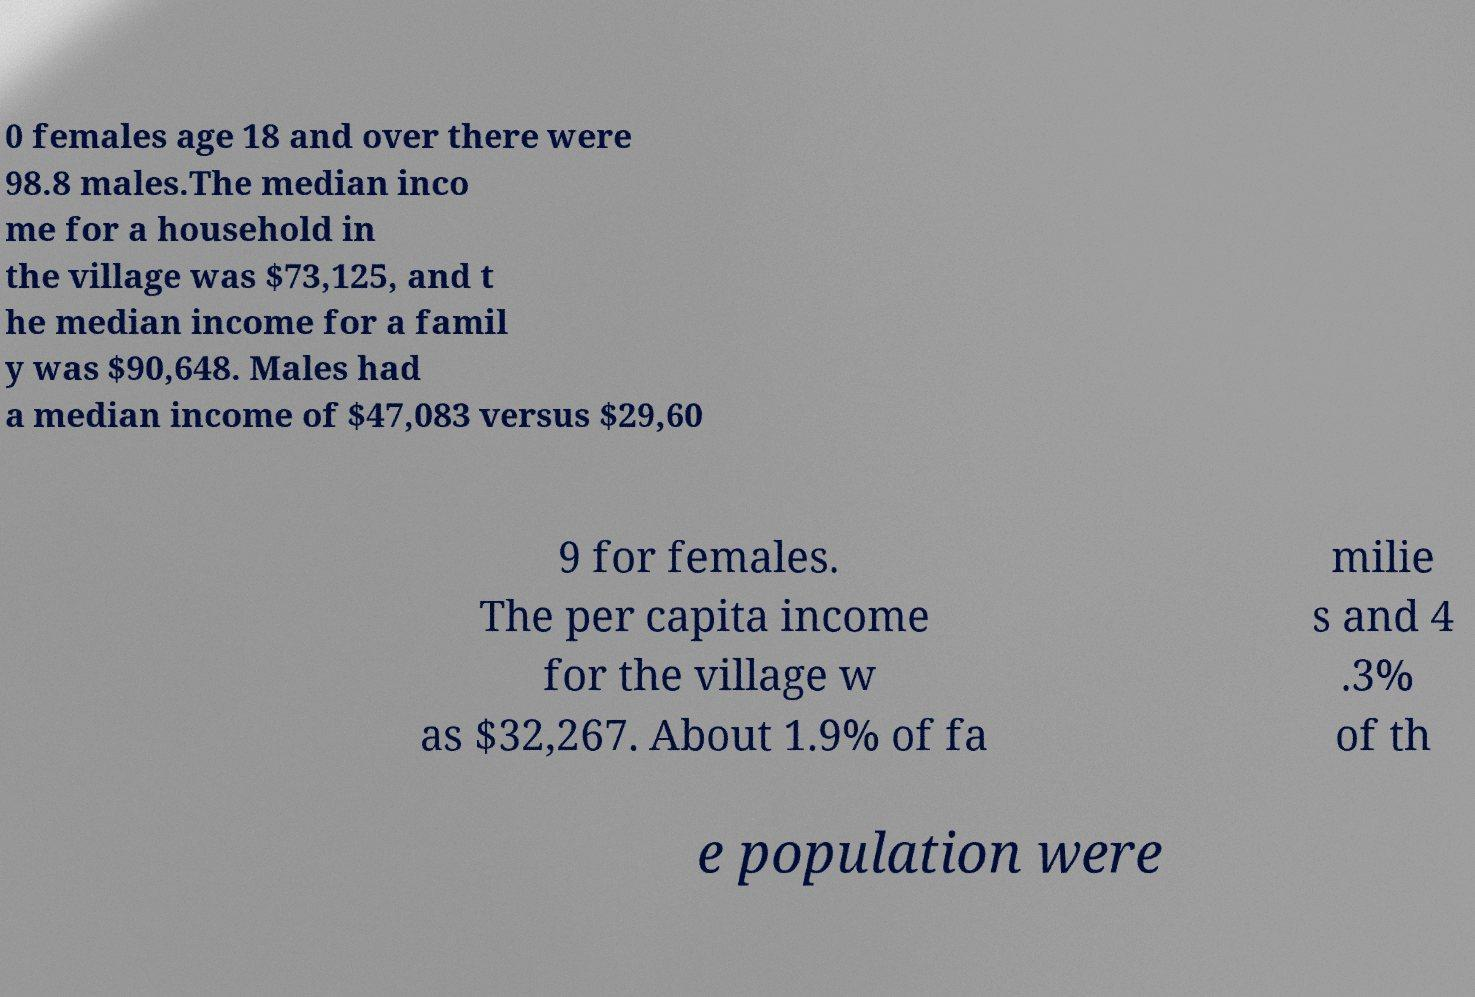Please identify and transcribe the text found in this image. 0 females age 18 and over there were 98.8 males.The median inco me for a household in the village was $73,125, and t he median income for a famil y was $90,648. Males had a median income of $47,083 versus $29,60 9 for females. The per capita income for the village w as $32,267. About 1.9% of fa milie s and 4 .3% of th e population were 